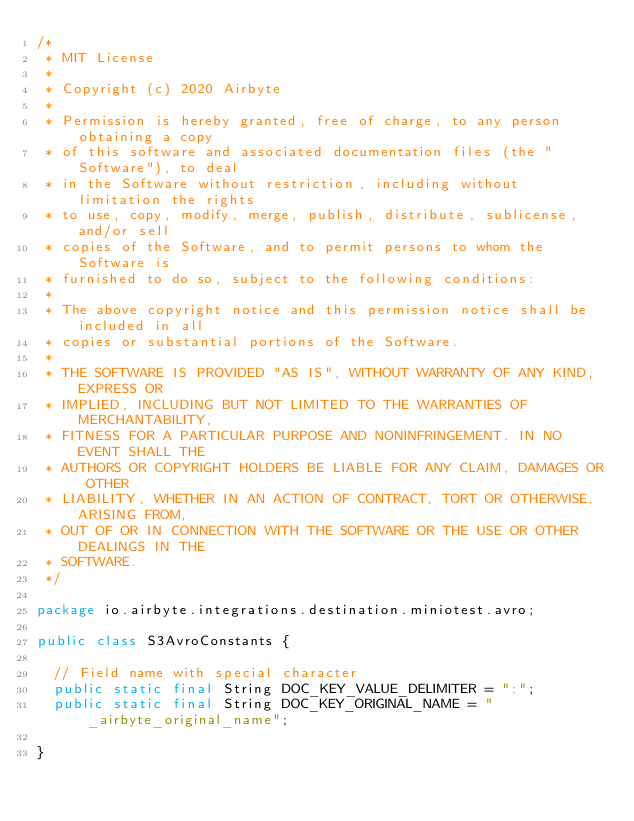Convert code to text. <code><loc_0><loc_0><loc_500><loc_500><_Java_>/*
 * MIT License
 *
 * Copyright (c) 2020 Airbyte
 *
 * Permission is hereby granted, free of charge, to any person obtaining a copy
 * of this software and associated documentation files (the "Software"), to deal
 * in the Software without restriction, including without limitation the rights
 * to use, copy, modify, merge, publish, distribute, sublicense, and/or sell
 * copies of the Software, and to permit persons to whom the Software is
 * furnished to do so, subject to the following conditions:
 *
 * The above copyright notice and this permission notice shall be included in all
 * copies or substantial portions of the Software.
 *
 * THE SOFTWARE IS PROVIDED "AS IS", WITHOUT WARRANTY OF ANY KIND, EXPRESS OR
 * IMPLIED, INCLUDING BUT NOT LIMITED TO THE WARRANTIES OF MERCHANTABILITY,
 * FITNESS FOR A PARTICULAR PURPOSE AND NONINFRINGEMENT. IN NO EVENT SHALL THE
 * AUTHORS OR COPYRIGHT HOLDERS BE LIABLE FOR ANY CLAIM, DAMAGES OR OTHER
 * LIABILITY, WHETHER IN AN ACTION OF CONTRACT, TORT OR OTHERWISE, ARISING FROM,
 * OUT OF OR IN CONNECTION WITH THE SOFTWARE OR THE USE OR OTHER DEALINGS IN THE
 * SOFTWARE.
 */

package io.airbyte.integrations.destination.miniotest.avro;

public class S3AvroConstants {

  // Field name with special character
  public static final String DOC_KEY_VALUE_DELIMITER = ":";
  public static final String DOC_KEY_ORIGINAL_NAME = "_airbyte_original_name";

}
</code> 